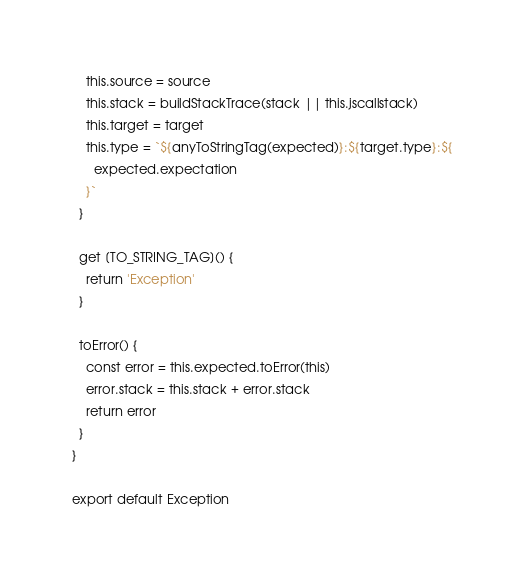Convert code to text. <code><loc_0><loc_0><loc_500><loc_500><_JavaScript_>    this.source = source
    this.stack = buildStackTrace(stack || this.jscallstack)
    this.target = target
    this.type = `${anyToStringTag(expected)}:${target.type}:${
      expected.expectation
    }`
  }

  get [TO_STRING_TAG]() {
    return 'Exception'
  }

  toError() {
    const error = this.expected.toError(this)
    error.stack = this.stack + error.stack
    return error
  }
}

export default Exception
</code> 